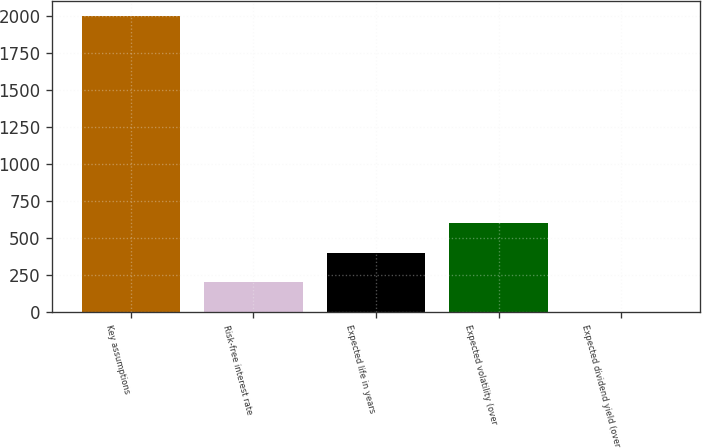Convert chart to OTSL. <chart><loc_0><loc_0><loc_500><loc_500><bar_chart><fcel>Key assumptions<fcel>Risk-free interest rate<fcel>Expected life in years<fcel>Expected volatility (over<fcel>Expected dividend yield (over<nl><fcel>2005<fcel>203.47<fcel>403.64<fcel>603.81<fcel>3.3<nl></chart> 